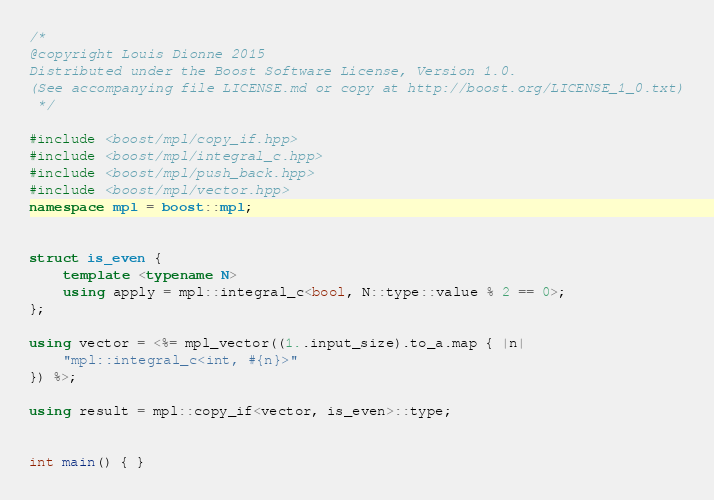Convert code to text. <code><loc_0><loc_0><loc_500><loc_500><_C++_>/*
@copyright Louis Dionne 2015
Distributed under the Boost Software License, Version 1.0.
(See accompanying file LICENSE.md or copy at http://boost.org/LICENSE_1_0.txt)
 */

#include <boost/mpl/copy_if.hpp>
#include <boost/mpl/integral_c.hpp>
#include <boost/mpl/push_back.hpp>
#include <boost/mpl/vector.hpp>
namespace mpl = boost::mpl;


struct is_even {
    template <typename N>
    using apply = mpl::integral_c<bool, N::type::value % 2 == 0>;
};

using vector = <%= mpl_vector((1..input_size).to_a.map { |n|
    "mpl::integral_c<int, #{n}>"
}) %>;

using result = mpl::copy_if<vector, is_even>::type;


int main() { }
</code> 